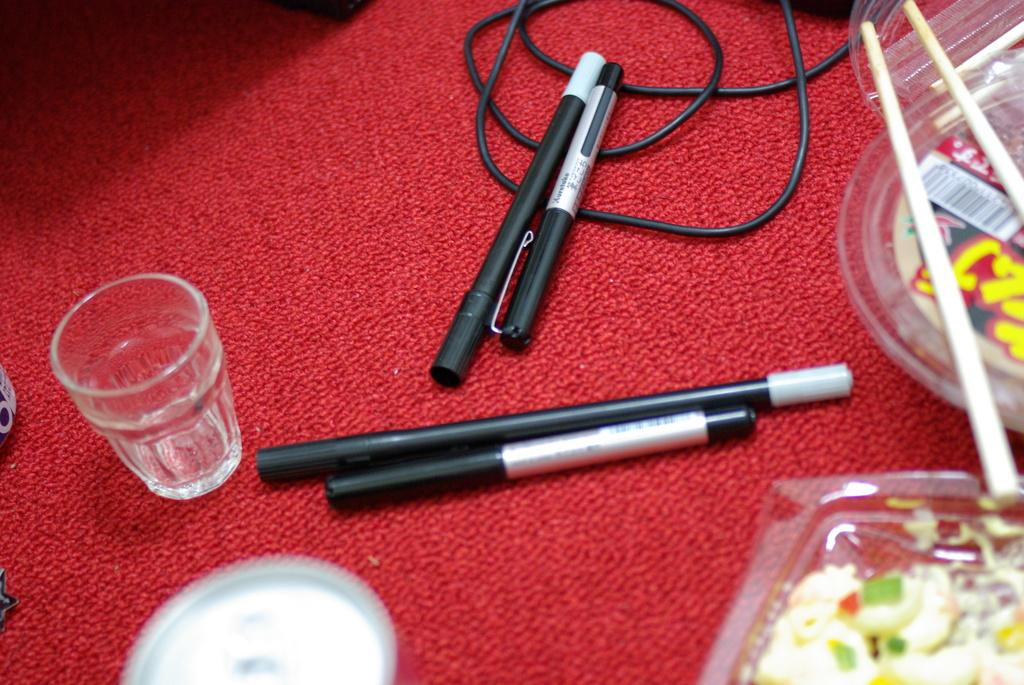What writing instruments are visible in the image? There are pens in the image. What type of container is present in the image? There is a glass in the image. What type of storage items can be seen in the image? There are boxes in the image. What type of consumable items are visible in the image? There are food items in the image. What type of electrical component is present in the image? There is a cable in the image. What type of surface is visible in the image? There are other objects on a mat in the image. Can you see a bird flying through the window in the image? There is no bird or window present in the image. What type of bag is visible on the mat in the image? There is no bag present on the mat in the image. 